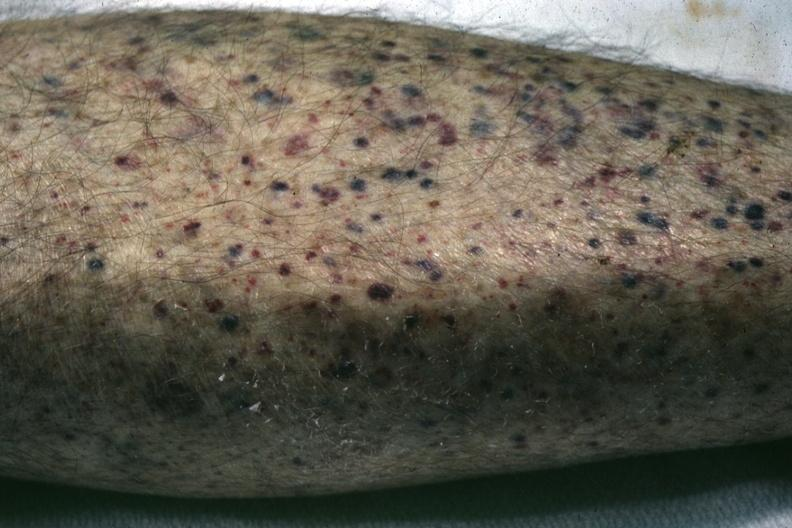where is this?
Answer the question using a single word or phrase. Skin 